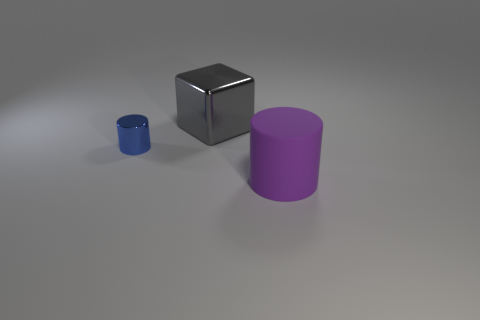Are there any other things that have the same shape as the gray metallic object?
Provide a succinct answer. No. What color is the thing to the left of the big gray metal block?
Your response must be concise. Blue. What size is the block that is the same material as the small cylinder?
Your response must be concise. Large. Is the size of the gray object the same as the thing that is left of the big gray object?
Give a very brief answer. No. What material is the large object in front of the small blue thing?
Make the answer very short. Rubber. There is a cylinder left of the big matte cylinder; how many gray metal cubes are in front of it?
Offer a terse response. 0. Is there a large rubber object of the same shape as the gray shiny thing?
Provide a succinct answer. No. There is a cylinder behind the big purple matte cylinder; is it the same size as the cylinder that is in front of the small blue cylinder?
Your answer should be very brief. No. There is a big thing that is left of the large rubber thing to the right of the large metal object; what is its shape?
Ensure brevity in your answer.  Cube. What number of blue metal cylinders have the same size as the matte thing?
Your answer should be very brief. 0. 